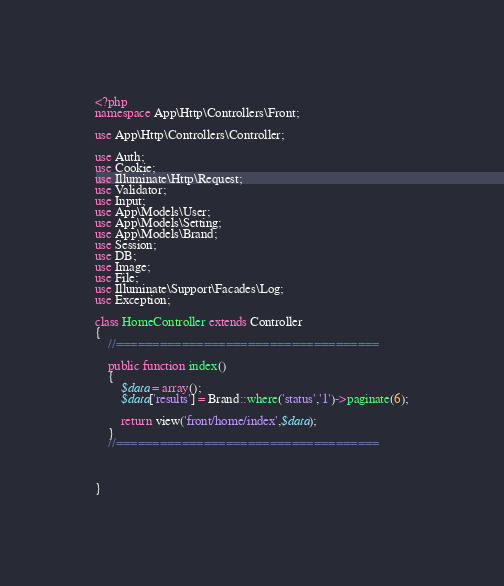Convert code to text. <code><loc_0><loc_0><loc_500><loc_500><_PHP_><?php
namespace App\Http\Controllers\Front;

use App\Http\Controllers\Controller;

use Auth;
use Cookie;
use Illuminate\Http\Request;
use Validator;
use Input;
use App\Models\User;
use App\Models\Setting;
use App\Models\Brand;
use Session;
use DB;
use Image;
use File;
use Illuminate\Support\Facades\Log;
use Exception;

class HomeController extends Controller
{
    //====================================

	public function index()
	{
		$data = array();
		$data['results'] = Brand::where('status','1')->paginate(6);

		return view('front/home/index',$data);
	}
	//====================================



}
</code> 